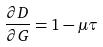Convert formula to latex. <formula><loc_0><loc_0><loc_500><loc_500>\frac { \partial D } { \partial G } = 1 - \mu \tau</formula> 